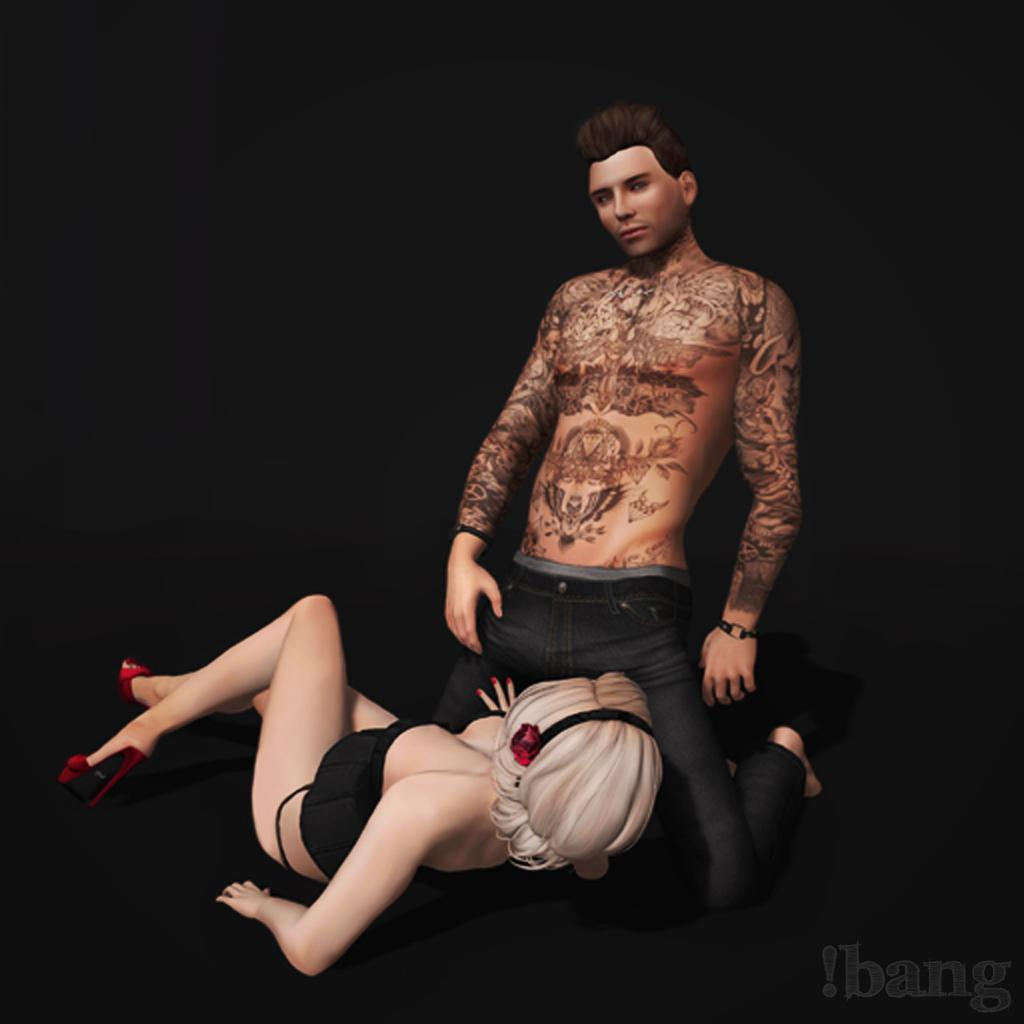How many people are present in the image? There are two people, a man and a woman, present in the image. What are the man and the woman wearing? Both the man and the woman are wearing clothes. Can you describe any accessories visible in the image? Yes, there is a sandal and a bracelet visible in the image. Is there any text or marking on the image? The image contains a watermark, which might not be a physical object in the image. How many girls are present in the image? The image does not show any girls; it features a man and a woman. What is the man's crush doing in the image? There is no information about a crush in the image, as it only shows a man and a woman. 